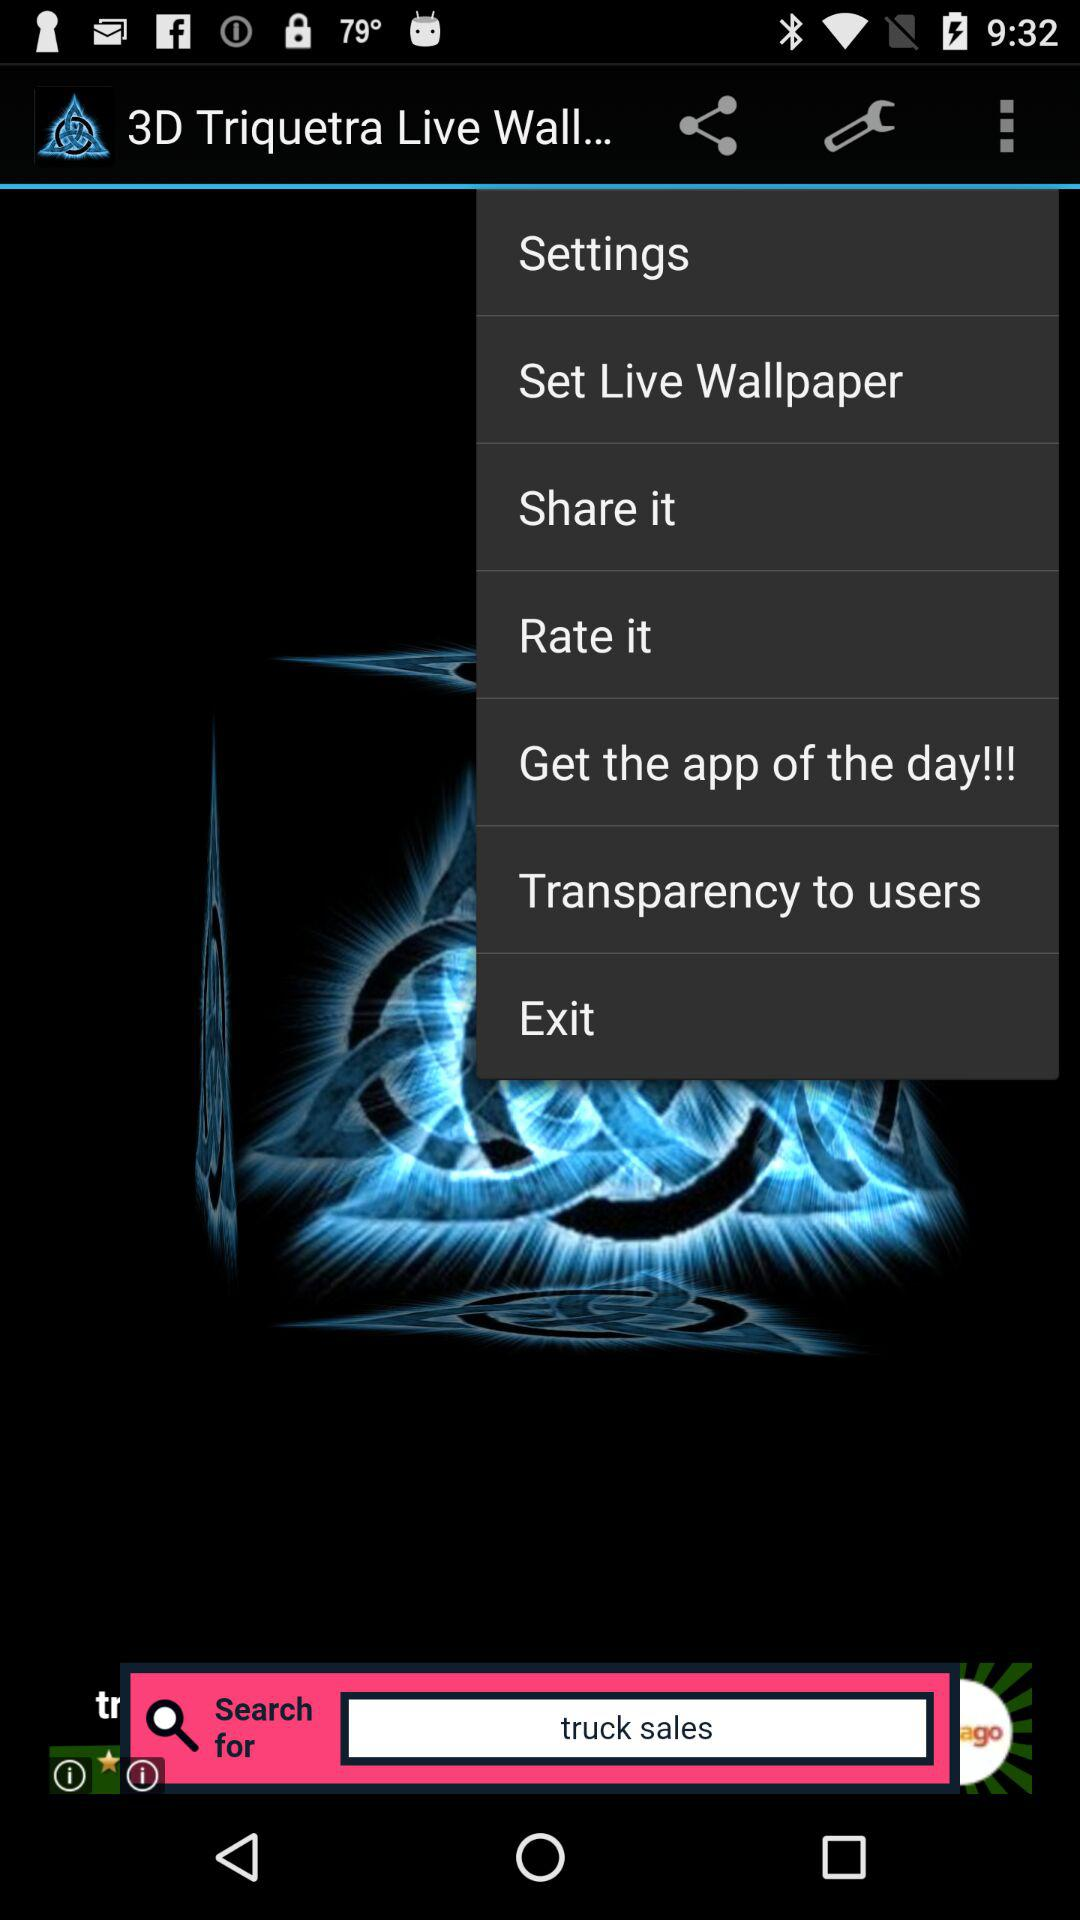What is the name of the application? The name of the application is "3D Triquetra Live Wallpaper". 